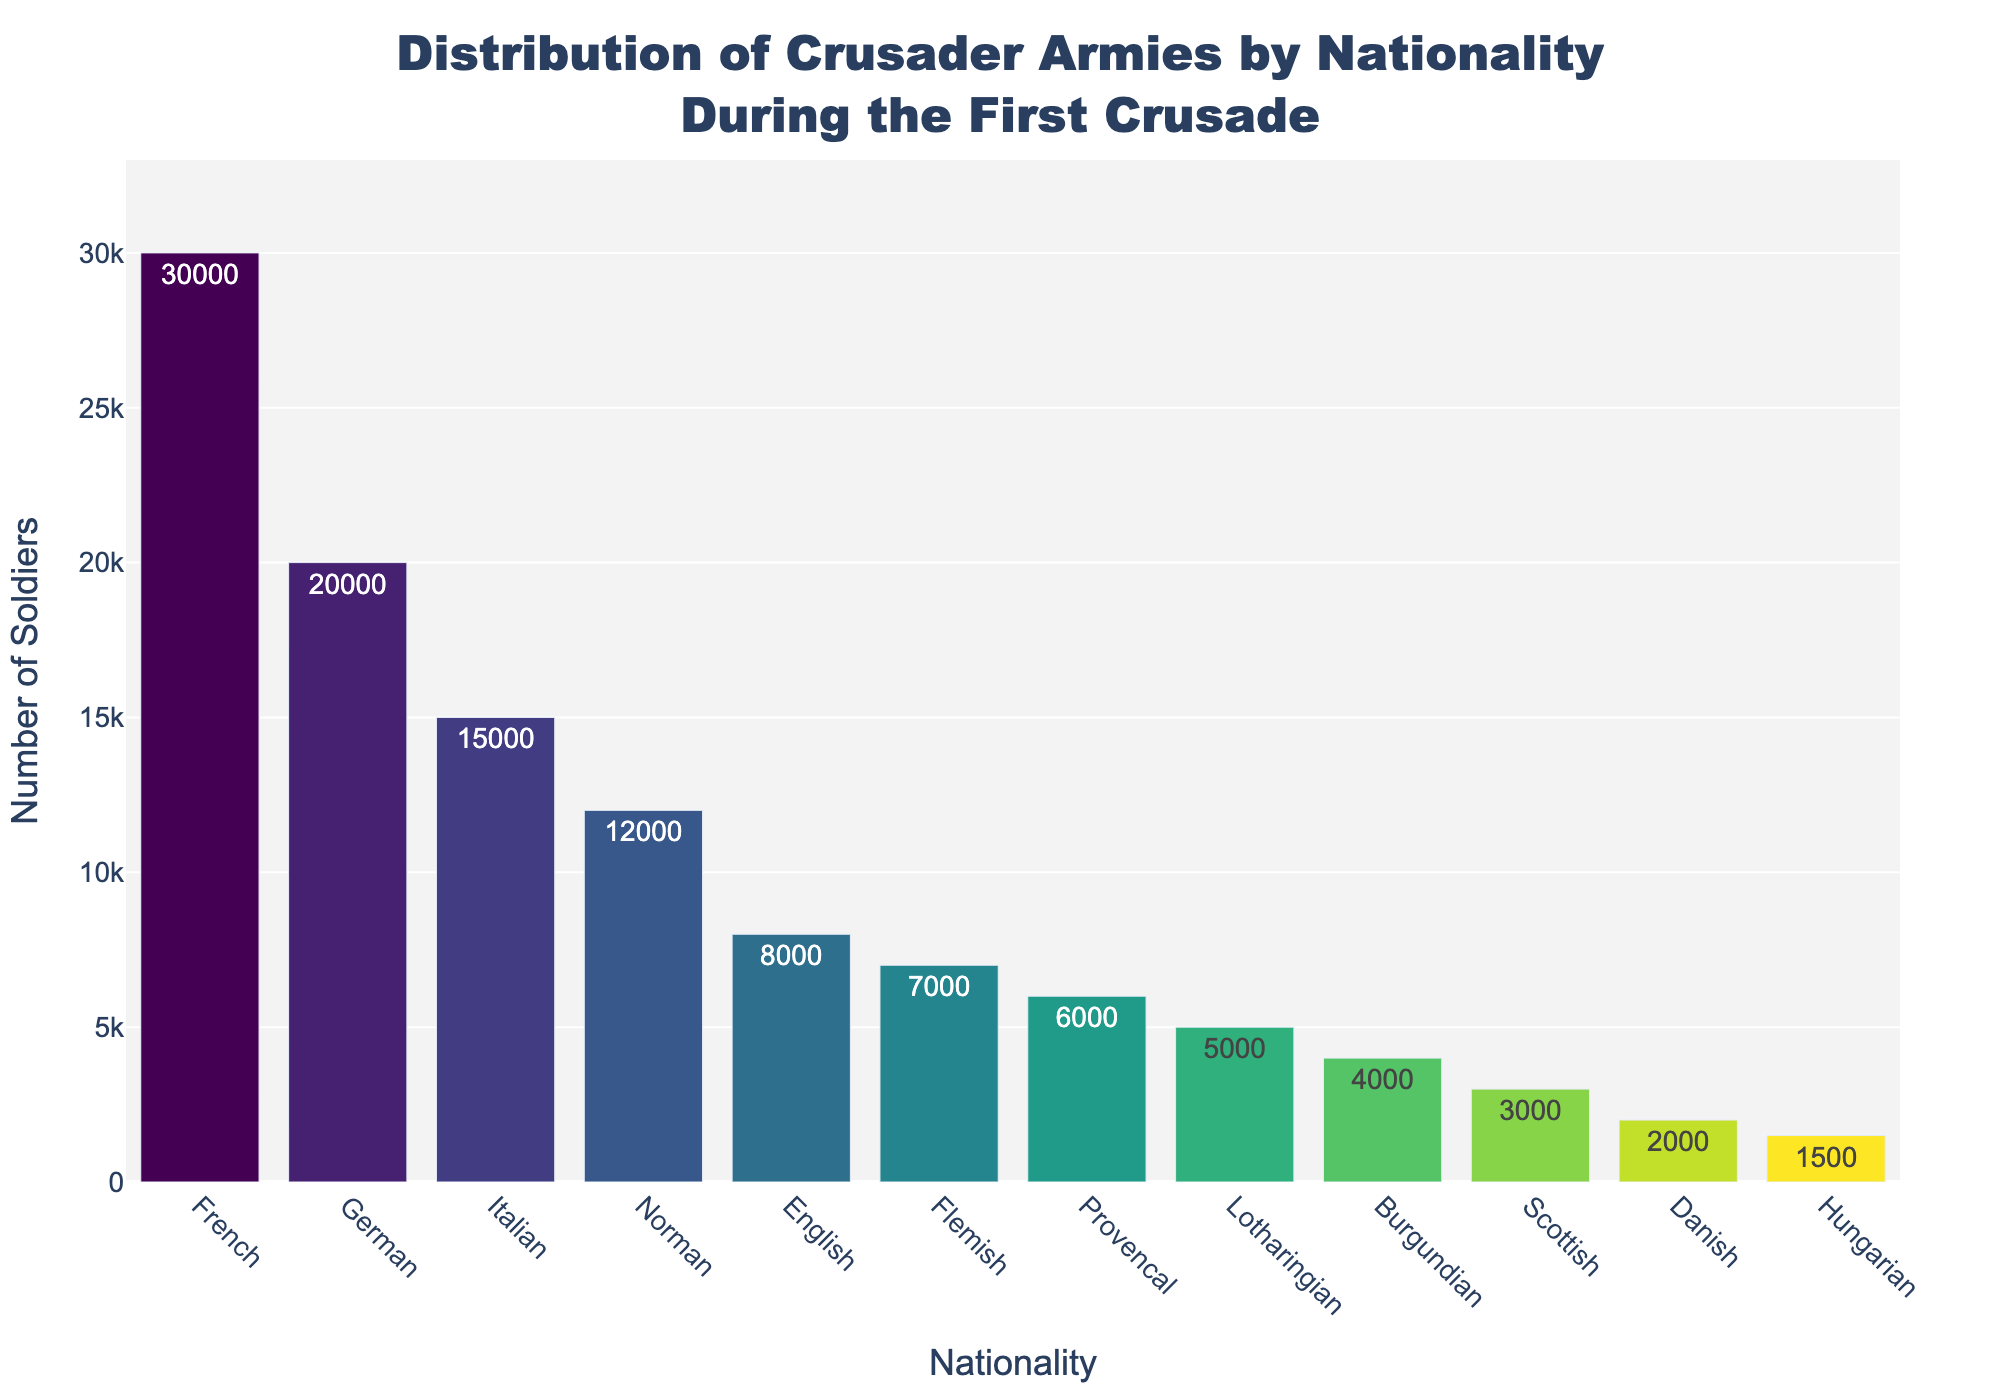What's the nationality with the highest number of soldiers? The bar with the highest value corresponds to the French, indicating that they have the most soldiers.
Answer: French Which two nationalities together contribute exactly 25,000 soldiers? Adding up the soldiers for Germans (20,000) and Hungarians (1,500) with other nationalities, we find that Flemish (7,000) and Provencal (6,000) amount to 13,000 and not 25,000. Check Danish (2,000) and Hungarian (1,500) with others, but they don't combine to 25,000.<br>Reviewing thoroughly, Italian (15,000) and Norman (12,000) total is nearly that sum but not exact. Finally,<br> German (20,000) and Lotharingian (5,000) sum to 25,000.
Answer: German and Lotharingian Among English, Danish, and Scottish, which nationality has the highest number of soldiers? Comparing the three: English (8,000), Danish (2,000), and Scottish (3,000), the English have the highest number.
Answer: English What is the difference in the number of soldiers between the French and the Normans? The number of French soldiers is 30,000 and the number of Norman soldiers is 12,000. The difference is calculated as 30,000 - 12,000 = 18,000.
Answer: 18,000 Which nationalities have an equal number of soldiers? By checking each entry for exact match in numbers, we find that no nationalities have exactly the same number of soldiers.
Answer: None What is the total number of soldiers from the top 3 nationalities? Summing up the top 3 nationalities: French (30,000) + German (20,000) + Italian (15,000) = 65,000.
Answer: 65,000 Which nationalities have fewer than 5,000 soldiers? Reviewing the numbers, the Lotharingian (5,000), Burgundian (4,000), Scottish (3,000), Danish (2,000), and Hungarian (1,500) nationalities have fewer than 5,000 soldiers.
Answer: Burgundian, Scottish, Danish, Hungarian What is the average number of soldiers across all nationalities? Adding the total number of soldiers: 30,000 (French) + 20,000 (German) + 15,000 (Italian) + 12,000 (Norman) + 8,000 (English) + 7,000 (Flemish) + 6,000 (Provencal) + 5,000 (Lotharingian) + 4,000 (Burgundian) + 3,000 (Scottish) + 2,000 (Danish) + 1,500 (Hungarian) = 113,500. There are 12 nationalities, so the average is 113,500 / 12 = 9,458.33.
Answer: 9,458.33 Among the nationalities, who contributed more soldiers - Normans or Provencals? Comparing the number of soldiers: Normans (12,000) and Provencals (6,000), Normans contributed more soldiers.
Answer: Normans 